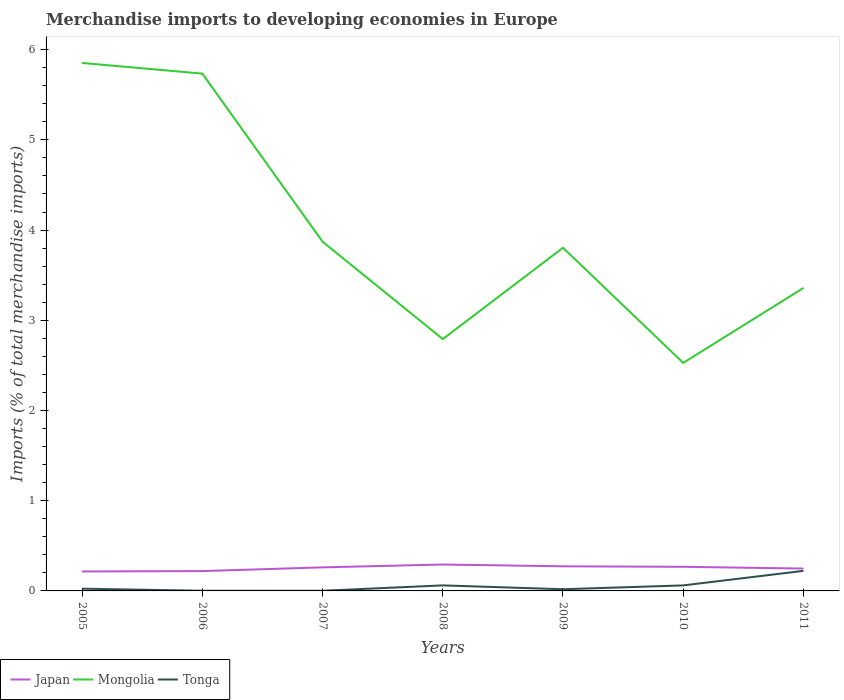Across all years, what is the maximum percentage total merchandise imports in Japan?
Keep it short and to the point. 0.22. What is the total percentage total merchandise imports in Japan in the graph?
Offer a terse response. -0.05. What is the difference between the highest and the second highest percentage total merchandise imports in Mongolia?
Your answer should be compact. 3.32. How many lines are there?
Provide a short and direct response. 3. How many years are there in the graph?
Give a very brief answer. 7. What is the difference between two consecutive major ticks on the Y-axis?
Your answer should be compact. 1. How many legend labels are there?
Offer a very short reply. 3. How are the legend labels stacked?
Offer a terse response. Horizontal. What is the title of the graph?
Your response must be concise. Merchandise imports to developing economies in Europe. Does "Portugal" appear as one of the legend labels in the graph?
Provide a short and direct response. No. What is the label or title of the X-axis?
Your response must be concise. Years. What is the label or title of the Y-axis?
Your response must be concise. Imports (% of total merchandise imports). What is the Imports (% of total merchandise imports) in Japan in 2005?
Your response must be concise. 0.22. What is the Imports (% of total merchandise imports) in Mongolia in 2005?
Offer a very short reply. 5.85. What is the Imports (% of total merchandise imports) of Tonga in 2005?
Provide a succinct answer. 0.02. What is the Imports (% of total merchandise imports) of Japan in 2006?
Provide a succinct answer. 0.22. What is the Imports (% of total merchandise imports) in Mongolia in 2006?
Ensure brevity in your answer.  5.73. What is the Imports (% of total merchandise imports) of Tonga in 2006?
Your response must be concise. 0. What is the Imports (% of total merchandise imports) of Japan in 2007?
Give a very brief answer. 0.26. What is the Imports (% of total merchandise imports) of Mongolia in 2007?
Keep it short and to the point. 3.87. What is the Imports (% of total merchandise imports) of Tonga in 2007?
Offer a very short reply. 0. What is the Imports (% of total merchandise imports) in Japan in 2008?
Provide a short and direct response. 0.29. What is the Imports (% of total merchandise imports) in Mongolia in 2008?
Provide a short and direct response. 2.79. What is the Imports (% of total merchandise imports) in Tonga in 2008?
Your answer should be very brief. 0.06. What is the Imports (% of total merchandise imports) of Japan in 2009?
Your response must be concise. 0.27. What is the Imports (% of total merchandise imports) in Mongolia in 2009?
Ensure brevity in your answer.  3.8. What is the Imports (% of total merchandise imports) of Tonga in 2009?
Your response must be concise. 0.02. What is the Imports (% of total merchandise imports) of Japan in 2010?
Your response must be concise. 0.27. What is the Imports (% of total merchandise imports) of Mongolia in 2010?
Provide a short and direct response. 2.53. What is the Imports (% of total merchandise imports) of Tonga in 2010?
Offer a terse response. 0.06. What is the Imports (% of total merchandise imports) in Japan in 2011?
Give a very brief answer. 0.25. What is the Imports (% of total merchandise imports) in Mongolia in 2011?
Keep it short and to the point. 3.36. What is the Imports (% of total merchandise imports) of Tonga in 2011?
Your response must be concise. 0.22. Across all years, what is the maximum Imports (% of total merchandise imports) of Japan?
Offer a very short reply. 0.29. Across all years, what is the maximum Imports (% of total merchandise imports) of Mongolia?
Provide a succinct answer. 5.85. Across all years, what is the maximum Imports (% of total merchandise imports) in Tonga?
Make the answer very short. 0.22. Across all years, what is the minimum Imports (% of total merchandise imports) of Japan?
Give a very brief answer. 0.22. Across all years, what is the minimum Imports (% of total merchandise imports) in Mongolia?
Keep it short and to the point. 2.53. Across all years, what is the minimum Imports (% of total merchandise imports) in Tonga?
Keep it short and to the point. 0. What is the total Imports (% of total merchandise imports) of Japan in the graph?
Give a very brief answer. 1.78. What is the total Imports (% of total merchandise imports) in Mongolia in the graph?
Keep it short and to the point. 27.94. What is the total Imports (% of total merchandise imports) in Tonga in the graph?
Ensure brevity in your answer.  0.39. What is the difference between the Imports (% of total merchandise imports) in Japan in 2005 and that in 2006?
Provide a short and direct response. -0. What is the difference between the Imports (% of total merchandise imports) of Mongolia in 2005 and that in 2006?
Your answer should be very brief. 0.12. What is the difference between the Imports (% of total merchandise imports) of Tonga in 2005 and that in 2006?
Provide a succinct answer. 0.02. What is the difference between the Imports (% of total merchandise imports) in Japan in 2005 and that in 2007?
Provide a succinct answer. -0.05. What is the difference between the Imports (% of total merchandise imports) of Mongolia in 2005 and that in 2007?
Your answer should be compact. 1.98. What is the difference between the Imports (% of total merchandise imports) of Tonga in 2005 and that in 2007?
Keep it short and to the point. 0.02. What is the difference between the Imports (% of total merchandise imports) in Japan in 2005 and that in 2008?
Your answer should be compact. -0.08. What is the difference between the Imports (% of total merchandise imports) of Mongolia in 2005 and that in 2008?
Offer a terse response. 3.06. What is the difference between the Imports (% of total merchandise imports) of Tonga in 2005 and that in 2008?
Offer a terse response. -0.04. What is the difference between the Imports (% of total merchandise imports) in Japan in 2005 and that in 2009?
Your answer should be very brief. -0.06. What is the difference between the Imports (% of total merchandise imports) in Mongolia in 2005 and that in 2009?
Your answer should be very brief. 2.05. What is the difference between the Imports (% of total merchandise imports) of Tonga in 2005 and that in 2009?
Make the answer very short. 0.01. What is the difference between the Imports (% of total merchandise imports) in Japan in 2005 and that in 2010?
Your response must be concise. -0.05. What is the difference between the Imports (% of total merchandise imports) of Mongolia in 2005 and that in 2010?
Your response must be concise. 3.32. What is the difference between the Imports (% of total merchandise imports) of Tonga in 2005 and that in 2010?
Your answer should be compact. -0.04. What is the difference between the Imports (% of total merchandise imports) in Japan in 2005 and that in 2011?
Offer a terse response. -0.03. What is the difference between the Imports (% of total merchandise imports) in Mongolia in 2005 and that in 2011?
Offer a very short reply. 2.49. What is the difference between the Imports (% of total merchandise imports) in Tonga in 2005 and that in 2011?
Your answer should be compact. -0.2. What is the difference between the Imports (% of total merchandise imports) of Japan in 2006 and that in 2007?
Provide a succinct answer. -0.04. What is the difference between the Imports (% of total merchandise imports) in Mongolia in 2006 and that in 2007?
Provide a succinct answer. 1.86. What is the difference between the Imports (% of total merchandise imports) of Tonga in 2006 and that in 2007?
Ensure brevity in your answer.  -0. What is the difference between the Imports (% of total merchandise imports) of Japan in 2006 and that in 2008?
Offer a very short reply. -0.07. What is the difference between the Imports (% of total merchandise imports) in Mongolia in 2006 and that in 2008?
Make the answer very short. 2.94. What is the difference between the Imports (% of total merchandise imports) in Tonga in 2006 and that in 2008?
Make the answer very short. -0.06. What is the difference between the Imports (% of total merchandise imports) in Japan in 2006 and that in 2009?
Your answer should be very brief. -0.05. What is the difference between the Imports (% of total merchandise imports) of Mongolia in 2006 and that in 2009?
Your answer should be compact. 1.93. What is the difference between the Imports (% of total merchandise imports) of Tonga in 2006 and that in 2009?
Keep it short and to the point. -0.02. What is the difference between the Imports (% of total merchandise imports) of Japan in 2006 and that in 2010?
Give a very brief answer. -0.05. What is the difference between the Imports (% of total merchandise imports) of Mongolia in 2006 and that in 2010?
Provide a succinct answer. 3.21. What is the difference between the Imports (% of total merchandise imports) of Tonga in 2006 and that in 2010?
Your response must be concise. -0.06. What is the difference between the Imports (% of total merchandise imports) in Japan in 2006 and that in 2011?
Give a very brief answer. -0.03. What is the difference between the Imports (% of total merchandise imports) of Mongolia in 2006 and that in 2011?
Make the answer very short. 2.38. What is the difference between the Imports (% of total merchandise imports) of Tonga in 2006 and that in 2011?
Keep it short and to the point. -0.22. What is the difference between the Imports (% of total merchandise imports) in Japan in 2007 and that in 2008?
Offer a terse response. -0.03. What is the difference between the Imports (% of total merchandise imports) of Mongolia in 2007 and that in 2008?
Ensure brevity in your answer.  1.08. What is the difference between the Imports (% of total merchandise imports) in Tonga in 2007 and that in 2008?
Your answer should be compact. -0.06. What is the difference between the Imports (% of total merchandise imports) of Japan in 2007 and that in 2009?
Give a very brief answer. -0.01. What is the difference between the Imports (% of total merchandise imports) of Mongolia in 2007 and that in 2009?
Give a very brief answer. 0.07. What is the difference between the Imports (% of total merchandise imports) of Tonga in 2007 and that in 2009?
Your response must be concise. -0.02. What is the difference between the Imports (% of total merchandise imports) of Japan in 2007 and that in 2010?
Provide a short and direct response. -0.01. What is the difference between the Imports (% of total merchandise imports) of Mongolia in 2007 and that in 2010?
Ensure brevity in your answer.  1.34. What is the difference between the Imports (% of total merchandise imports) of Tonga in 2007 and that in 2010?
Give a very brief answer. -0.06. What is the difference between the Imports (% of total merchandise imports) in Japan in 2007 and that in 2011?
Give a very brief answer. 0.01. What is the difference between the Imports (% of total merchandise imports) of Mongolia in 2007 and that in 2011?
Provide a succinct answer. 0.51. What is the difference between the Imports (% of total merchandise imports) in Tonga in 2007 and that in 2011?
Provide a short and direct response. -0.22. What is the difference between the Imports (% of total merchandise imports) in Japan in 2008 and that in 2009?
Offer a very short reply. 0.02. What is the difference between the Imports (% of total merchandise imports) of Mongolia in 2008 and that in 2009?
Ensure brevity in your answer.  -1.01. What is the difference between the Imports (% of total merchandise imports) in Tonga in 2008 and that in 2009?
Make the answer very short. 0.04. What is the difference between the Imports (% of total merchandise imports) in Japan in 2008 and that in 2010?
Provide a succinct answer. 0.03. What is the difference between the Imports (% of total merchandise imports) in Mongolia in 2008 and that in 2010?
Give a very brief answer. 0.26. What is the difference between the Imports (% of total merchandise imports) of Japan in 2008 and that in 2011?
Ensure brevity in your answer.  0.04. What is the difference between the Imports (% of total merchandise imports) of Mongolia in 2008 and that in 2011?
Offer a terse response. -0.57. What is the difference between the Imports (% of total merchandise imports) in Tonga in 2008 and that in 2011?
Your response must be concise. -0.16. What is the difference between the Imports (% of total merchandise imports) of Japan in 2009 and that in 2010?
Your response must be concise. 0.01. What is the difference between the Imports (% of total merchandise imports) of Mongolia in 2009 and that in 2010?
Give a very brief answer. 1.28. What is the difference between the Imports (% of total merchandise imports) of Tonga in 2009 and that in 2010?
Provide a short and direct response. -0.04. What is the difference between the Imports (% of total merchandise imports) of Japan in 2009 and that in 2011?
Provide a succinct answer. 0.02. What is the difference between the Imports (% of total merchandise imports) of Mongolia in 2009 and that in 2011?
Your response must be concise. 0.45. What is the difference between the Imports (% of total merchandise imports) of Tonga in 2009 and that in 2011?
Your answer should be very brief. -0.2. What is the difference between the Imports (% of total merchandise imports) of Japan in 2010 and that in 2011?
Offer a terse response. 0.02. What is the difference between the Imports (% of total merchandise imports) in Mongolia in 2010 and that in 2011?
Offer a terse response. -0.83. What is the difference between the Imports (% of total merchandise imports) of Tonga in 2010 and that in 2011?
Your response must be concise. -0.16. What is the difference between the Imports (% of total merchandise imports) in Japan in 2005 and the Imports (% of total merchandise imports) in Mongolia in 2006?
Your answer should be very brief. -5.52. What is the difference between the Imports (% of total merchandise imports) of Japan in 2005 and the Imports (% of total merchandise imports) of Tonga in 2006?
Give a very brief answer. 0.21. What is the difference between the Imports (% of total merchandise imports) of Mongolia in 2005 and the Imports (% of total merchandise imports) of Tonga in 2006?
Provide a short and direct response. 5.85. What is the difference between the Imports (% of total merchandise imports) in Japan in 2005 and the Imports (% of total merchandise imports) in Mongolia in 2007?
Provide a short and direct response. -3.66. What is the difference between the Imports (% of total merchandise imports) in Japan in 2005 and the Imports (% of total merchandise imports) in Tonga in 2007?
Offer a very short reply. 0.21. What is the difference between the Imports (% of total merchandise imports) in Mongolia in 2005 and the Imports (% of total merchandise imports) in Tonga in 2007?
Offer a terse response. 5.85. What is the difference between the Imports (% of total merchandise imports) in Japan in 2005 and the Imports (% of total merchandise imports) in Mongolia in 2008?
Provide a succinct answer. -2.58. What is the difference between the Imports (% of total merchandise imports) in Japan in 2005 and the Imports (% of total merchandise imports) in Tonga in 2008?
Offer a terse response. 0.15. What is the difference between the Imports (% of total merchandise imports) of Mongolia in 2005 and the Imports (% of total merchandise imports) of Tonga in 2008?
Offer a very short reply. 5.79. What is the difference between the Imports (% of total merchandise imports) of Japan in 2005 and the Imports (% of total merchandise imports) of Mongolia in 2009?
Your response must be concise. -3.59. What is the difference between the Imports (% of total merchandise imports) in Japan in 2005 and the Imports (% of total merchandise imports) in Tonga in 2009?
Provide a short and direct response. 0.2. What is the difference between the Imports (% of total merchandise imports) in Mongolia in 2005 and the Imports (% of total merchandise imports) in Tonga in 2009?
Your answer should be very brief. 5.83. What is the difference between the Imports (% of total merchandise imports) of Japan in 2005 and the Imports (% of total merchandise imports) of Mongolia in 2010?
Offer a very short reply. -2.31. What is the difference between the Imports (% of total merchandise imports) of Japan in 2005 and the Imports (% of total merchandise imports) of Tonga in 2010?
Make the answer very short. 0.15. What is the difference between the Imports (% of total merchandise imports) in Mongolia in 2005 and the Imports (% of total merchandise imports) in Tonga in 2010?
Your answer should be compact. 5.79. What is the difference between the Imports (% of total merchandise imports) of Japan in 2005 and the Imports (% of total merchandise imports) of Mongolia in 2011?
Your answer should be very brief. -3.14. What is the difference between the Imports (% of total merchandise imports) of Japan in 2005 and the Imports (% of total merchandise imports) of Tonga in 2011?
Keep it short and to the point. -0.01. What is the difference between the Imports (% of total merchandise imports) of Mongolia in 2005 and the Imports (% of total merchandise imports) of Tonga in 2011?
Your answer should be compact. 5.63. What is the difference between the Imports (% of total merchandise imports) in Japan in 2006 and the Imports (% of total merchandise imports) in Mongolia in 2007?
Provide a short and direct response. -3.65. What is the difference between the Imports (% of total merchandise imports) in Japan in 2006 and the Imports (% of total merchandise imports) in Tonga in 2007?
Your answer should be compact. 0.22. What is the difference between the Imports (% of total merchandise imports) in Mongolia in 2006 and the Imports (% of total merchandise imports) in Tonga in 2007?
Make the answer very short. 5.73. What is the difference between the Imports (% of total merchandise imports) of Japan in 2006 and the Imports (% of total merchandise imports) of Mongolia in 2008?
Your answer should be very brief. -2.57. What is the difference between the Imports (% of total merchandise imports) of Japan in 2006 and the Imports (% of total merchandise imports) of Tonga in 2008?
Your answer should be very brief. 0.16. What is the difference between the Imports (% of total merchandise imports) in Mongolia in 2006 and the Imports (% of total merchandise imports) in Tonga in 2008?
Offer a very short reply. 5.67. What is the difference between the Imports (% of total merchandise imports) of Japan in 2006 and the Imports (% of total merchandise imports) of Mongolia in 2009?
Offer a terse response. -3.58. What is the difference between the Imports (% of total merchandise imports) of Japan in 2006 and the Imports (% of total merchandise imports) of Tonga in 2009?
Offer a terse response. 0.2. What is the difference between the Imports (% of total merchandise imports) of Mongolia in 2006 and the Imports (% of total merchandise imports) of Tonga in 2009?
Give a very brief answer. 5.72. What is the difference between the Imports (% of total merchandise imports) of Japan in 2006 and the Imports (% of total merchandise imports) of Mongolia in 2010?
Make the answer very short. -2.31. What is the difference between the Imports (% of total merchandise imports) in Japan in 2006 and the Imports (% of total merchandise imports) in Tonga in 2010?
Make the answer very short. 0.16. What is the difference between the Imports (% of total merchandise imports) in Mongolia in 2006 and the Imports (% of total merchandise imports) in Tonga in 2010?
Keep it short and to the point. 5.67. What is the difference between the Imports (% of total merchandise imports) in Japan in 2006 and the Imports (% of total merchandise imports) in Mongolia in 2011?
Offer a very short reply. -3.14. What is the difference between the Imports (% of total merchandise imports) of Japan in 2006 and the Imports (% of total merchandise imports) of Tonga in 2011?
Offer a very short reply. -0. What is the difference between the Imports (% of total merchandise imports) of Mongolia in 2006 and the Imports (% of total merchandise imports) of Tonga in 2011?
Provide a short and direct response. 5.51. What is the difference between the Imports (% of total merchandise imports) in Japan in 2007 and the Imports (% of total merchandise imports) in Mongolia in 2008?
Make the answer very short. -2.53. What is the difference between the Imports (% of total merchandise imports) in Japan in 2007 and the Imports (% of total merchandise imports) in Tonga in 2008?
Give a very brief answer. 0.2. What is the difference between the Imports (% of total merchandise imports) in Mongolia in 2007 and the Imports (% of total merchandise imports) in Tonga in 2008?
Offer a terse response. 3.81. What is the difference between the Imports (% of total merchandise imports) of Japan in 2007 and the Imports (% of total merchandise imports) of Mongolia in 2009?
Keep it short and to the point. -3.54. What is the difference between the Imports (% of total merchandise imports) in Japan in 2007 and the Imports (% of total merchandise imports) in Tonga in 2009?
Give a very brief answer. 0.24. What is the difference between the Imports (% of total merchandise imports) in Mongolia in 2007 and the Imports (% of total merchandise imports) in Tonga in 2009?
Ensure brevity in your answer.  3.85. What is the difference between the Imports (% of total merchandise imports) of Japan in 2007 and the Imports (% of total merchandise imports) of Mongolia in 2010?
Your answer should be compact. -2.27. What is the difference between the Imports (% of total merchandise imports) in Mongolia in 2007 and the Imports (% of total merchandise imports) in Tonga in 2010?
Your answer should be compact. 3.81. What is the difference between the Imports (% of total merchandise imports) in Japan in 2007 and the Imports (% of total merchandise imports) in Mongolia in 2011?
Provide a short and direct response. -3.1. What is the difference between the Imports (% of total merchandise imports) of Japan in 2007 and the Imports (% of total merchandise imports) of Tonga in 2011?
Provide a succinct answer. 0.04. What is the difference between the Imports (% of total merchandise imports) in Mongolia in 2007 and the Imports (% of total merchandise imports) in Tonga in 2011?
Offer a terse response. 3.65. What is the difference between the Imports (% of total merchandise imports) in Japan in 2008 and the Imports (% of total merchandise imports) in Mongolia in 2009?
Offer a terse response. -3.51. What is the difference between the Imports (% of total merchandise imports) of Japan in 2008 and the Imports (% of total merchandise imports) of Tonga in 2009?
Keep it short and to the point. 0.27. What is the difference between the Imports (% of total merchandise imports) of Mongolia in 2008 and the Imports (% of total merchandise imports) of Tonga in 2009?
Provide a succinct answer. 2.77. What is the difference between the Imports (% of total merchandise imports) of Japan in 2008 and the Imports (% of total merchandise imports) of Mongolia in 2010?
Offer a very short reply. -2.24. What is the difference between the Imports (% of total merchandise imports) in Japan in 2008 and the Imports (% of total merchandise imports) in Tonga in 2010?
Provide a short and direct response. 0.23. What is the difference between the Imports (% of total merchandise imports) of Mongolia in 2008 and the Imports (% of total merchandise imports) of Tonga in 2010?
Your response must be concise. 2.73. What is the difference between the Imports (% of total merchandise imports) of Japan in 2008 and the Imports (% of total merchandise imports) of Mongolia in 2011?
Provide a succinct answer. -3.07. What is the difference between the Imports (% of total merchandise imports) of Japan in 2008 and the Imports (% of total merchandise imports) of Tonga in 2011?
Provide a succinct answer. 0.07. What is the difference between the Imports (% of total merchandise imports) in Mongolia in 2008 and the Imports (% of total merchandise imports) in Tonga in 2011?
Make the answer very short. 2.57. What is the difference between the Imports (% of total merchandise imports) in Japan in 2009 and the Imports (% of total merchandise imports) in Mongolia in 2010?
Your answer should be compact. -2.25. What is the difference between the Imports (% of total merchandise imports) in Japan in 2009 and the Imports (% of total merchandise imports) in Tonga in 2010?
Offer a very short reply. 0.21. What is the difference between the Imports (% of total merchandise imports) of Mongolia in 2009 and the Imports (% of total merchandise imports) of Tonga in 2010?
Your answer should be compact. 3.74. What is the difference between the Imports (% of total merchandise imports) of Japan in 2009 and the Imports (% of total merchandise imports) of Mongolia in 2011?
Make the answer very short. -3.09. What is the difference between the Imports (% of total merchandise imports) of Japan in 2009 and the Imports (% of total merchandise imports) of Tonga in 2011?
Provide a short and direct response. 0.05. What is the difference between the Imports (% of total merchandise imports) in Mongolia in 2009 and the Imports (% of total merchandise imports) in Tonga in 2011?
Ensure brevity in your answer.  3.58. What is the difference between the Imports (% of total merchandise imports) in Japan in 2010 and the Imports (% of total merchandise imports) in Mongolia in 2011?
Give a very brief answer. -3.09. What is the difference between the Imports (% of total merchandise imports) in Japan in 2010 and the Imports (% of total merchandise imports) in Tonga in 2011?
Ensure brevity in your answer.  0.04. What is the difference between the Imports (% of total merchandise imports) in Mongolia in 2010 and the Imports (% of total merchandise imports) in Tonga in 2011?
Offer a terse response. 2.31. What is the average Imports (% of total merchandise imports) in Japan per year?
Give a very brief answer. 0.25. What is the average Imports (% of total merchandise imports) in Mongolia per year?
Ensure brevity in your answer.  3.99. What is the average Imports (% of total merchandise imports) in Tonga per year?
Provide a short and direct response. 0.06. In the year 2005, what is the difference between the Imports (% of total merchandise imports) in Japan and Imports (% of total merchandise imports) in Mongolia?
Provide a short and direct response. -5.64. In the year 2005, what is the difference between the Imports (% of total merchandise imports) in Japan and Imports (% of total merchandise imports) in Tonga?
Keep it short and to the point. 0.19. In the year 2005, what is the difference between the Imports (% of total merchandise imports) in Mongolia and Imports (% of total merchandise imports) in Tonga?
Make the answer very short. 5.83. In the year 2006, what is the difference between the Imports (% of total merchandise imports) in Japan and Imports (% of total merchandise imports) in Mongolia?
Your answer should be compact. -5.51. In the year 2006, what is the difference between the Imports (% of total merchandise imports) in Japan and Imports (% of total merchandise imports) in Tonga?
Your answer should be compact. 0.22. In the year 2006, what is the difference between the Imports (% of total merchandise imports) of Mongolia and Imports (% of total merchandise imports) of Tonga?
Give a very brief answer. 5.73. In the year 2007, what is the difference between the Imports (% of total merchandise imports) in Japan and Imports (% of total merchandise imports) in Mongolia?
Provide a short and direct response. -3.61. In the year 2007, what is the difference between the Imports (% of total merchandise imports) in Japan and Imports (% of total merchandise imports) in Tonga?
Make the answer very short. 0.26. In the year 2007, what is the difference between the Imports (% of total merchandise imports) in Mongolia and Imports (% of total merchandise imports) in Tonga?
Provide a short and direct response. 3.87. In the year 2008, what is the difference between the Imports (% of total merchandise imports) of Japan and Imports (% of total merchandise imports) of Mongolia?
Your response must be concise. -2.5. In the year 2008, what is the difference between the Imports (% of total merchandise imports) in Japan and Imports (% of total merchandise imports) in Tonga?
Your answer should be very brief. 0.23. In the year 2008, what is the difference between the Imports (% of total merchandise imports) of Mongolia and Imports (% of total merchandise imports) of Tonga?
Provide a short and direct response. 2.73. In the year 2009, what is the difference between the Imports (% of total merchandise imports) of Japan and Imports (% of total merchandise imports) of Mongolia?
Your answer should be very brief. -3.53. In the year 2009, what is the difference between the Imports (% of total merchandise imports) of Japan and Imports (% of total merchandise imports) of Tonga?
Your response must be concise. 0.25. In the year 2009, what is the difference between the Imports (% of total merchandise imports) of Mongolia and Imports (% of total merchandise imports) of Tonga?
Provide a short and direct response. 3.79. In the year 2010, what is the difference between the Imports (% of total merchandise imports) of Japan and Imports (% of total merchandise imports) of Mongolia?
Give a very brief answer. -2.26. In the year 2010, what is the difference between the Imports (% of total merchandise imports) of Japan and Imports (% of total merchandise imports) of Tonga?
Offer a terse response. 0.21. In the year 2010, what is the difference between the Imports (% of total merchandise imports) of Mongolia and Imports (% of total merchandise imports) of Tonga?
Offer a terse response. 2.47. In the year 2011, what is the difference between the Imports (% of total merchandise imports) of Japan and Imports (% of total merchandise imports) of Mongolia?
Provide a succinct answer. -3.11. In the year 2011, what is the difference between the Imports (% of total merchandise imports) of Japan and Imports (% of total merchandise imports) of Tonga?
Your answer should be very brief. 0.03. In the year 2011, what is the difference between the Imports (% of total merchandise imports) of Mongolia and Imports (% of total merchandise imports) of Tonga?
Make the answer very short. 3.14. What is the ratio of the Imports (% of total merchandise imports) of Japan in 2005 to that in 2006?
Your answer should be compact. 0.98. What is the ratio of the Imports (% of total merchandise imports) in Mongolia in 2005 to that in 2006?
Provide a short and direct response. 1.02. What is the ratio of the Imports (% of total merchandise imports) of Tonga in 2005 to that in 2006?
Your answer should be compact. 13.4. What is the ratio of the Imports (% of total merchandise imports) of Japan in 2005 to that in 2007?
Offer a terse response. 0.82. What is the ratio of the Imports (% of total merchandise imports) of Mongolia in 2005 to that in 2007?
Give a very brief answer. 1.51. What is the ratio of the Imports (% of total merchandise imports) of Tonga in 2005 to that in 2007?
Offer a terse response. 13.04. What is the ratio of the Imports (% of total merchandise imports) in Japan in 2005 to that in 2008?
Provide a succinct answer. 0.74. What is the ratio of the Imports (% of total merchandise imports) of Mongolia in 2005 to that in 2008?
Offer a terse response. 2.1. What is the ratio of the Imports (% of total merchandise imports) in Tonga in 2005 to that in 2008?
Make the answer very short. 0.41. What is the ratio of the Imports (% of total merchandise imports) in Japan in 2005 to that in 2009?
Ensure brevity in your answer.  0.79. What is the ratio of the Imports (% of total merchandise imports) in Mongolia in 2005 to that in 2009?
Your answer should be very brief. 1.54. What is the ratio of the Imports (% of total merchandise imports) of Tonga in 2005 to that in 2009?
Give a very brief answer. 1.33. What is the ratio of the Imports (% of total merchandise imports) of Japan in 2005 to that in 2010?
Your answer should be very brief. 0.81. What is the ratio of the Imports (% of total merchandise imports) in Mongolia in 2005 to that in 2010?
Keep it short and to the point. 2.32. What is the ratio of the Imports (% of total merchandise imports) in Tonga in 2005 to that in 2010?
Your answer should be compact. 0.41. What is the ratio of the Imports (% of total merchandise imports) of Japan in 2005 to that in 2011?
Offer a very short reply. 0.87. What is the ratio of the Imports (% of total merchandise imports) of Mongolia in 2005 to that in 2011?
Offer a terse response. 1.74. What is the ratio of the Imports (% of total merchandise imports) of Tonga in 2005 to that in 2011?
Give a very brief answer. 0.11. What is the ratio of the Imports (% of total merchandise imports) in Japan in 2006 to that in 2007?
Give a very brief answer. 0.84. What is the ratio of the Imports (% of total merchandise imports) of Mongolia in 2006 to that in 2007?
Offer a terse response. 1.48. What is the ratio of the Imports (% of total merchandise imports) in Tonga in 2006 to that in 2007?
Offer a terse response. 0.97. What is the ratio of the Imports (% of total merchandise imports) of Japan in 2006 to that in 2008?
Provide a succinct answer. 0.75. What is the ratio of the Imports (% of total merchandise imports) of Mongolia in 2006 to that in 2008?
Make the answer very short. 2.05. What is the ratio of the Imports (% of total merchandise imports) of Tonga in 2006 to that in 2008?
Offer a very short reply. 0.03. What is the ratio of the Imports (% of total merchandise imports) of Japan in 2006 to that in 2009?
Give a very brief answer. 0.81. What is the ratio of the Imports (% of total merchandise imports) of Mongolia in 2006 to that in 2009?
Keep it short and to the point. 1.51. What is the ratio of the Imports (% of total merchandise imports) of Tonga in 2006 to that in 2009?
Offer a very short reply. 0.1. What is the ratio of the Imports (% of total merchandise imports) of Japan in 2006 to that in 2010?
Give a very brief answer. 0.82. What is the ratio of the Imports (% of total merchandise imports) in Mongolia in 2006 to that in 2010?
Offer a very short reply. 2.27. What is the ratio of the Imports (% of total merchandise imports) of Tonga in 2006 to that in 2010?
Provide a short and direct response. 0.03. What is the ratio of the Imports (% of total merchandise imports) of Japan in 2006 to that in 2011?
Make the answer very short. 0.89. What is the ratio of the Imports (% of total merchandise imports) in Mongolia in 2006 to that in 2011?
Offer a terse response. 1.71. What is the ratio of the Imports (% of total merchandise imports) in Tonga in 2006 to that in 2011?
Keep it short and to the point. 0.01. What is the ratio of the Imports (% of total merchandise imports) of Japan in 2007 to that in 2008?
Offer a very short reply. 0.89. What is the ratio of the Imports (% of total merchandise imports) in Mongolia in 2007 to that in 2008?
Offer a terse response. 1.39. What is the ratio of the Imports (% of total merchandise imports) in Tonga in 2007 to that in 2008?
Make the answer very short. 0.03. What is the ratio of the Imports (% of total merchandise imports) of Japan in 2007 to that in 2009?
Ensure brevity in your answer.  0.96. What is the ratio of the Imports (% of total merchandise imports) of Mongolia in 2007 to that in 2009?
Keep it short and to the point. 1.02. What is the ratio of the Imports (% of total merchandise imports) in Tonga in 2007 to that in 2009?
Your response must be concise. 0.1. What is the ratio of the Imports (% of total merchandise imports) in Japan in 2007 to that in 2010?
Ensure brevity in your answer.  0.98. What is the ratio of the Imports (% of total merchandise imports) in Mongolia in 2007 to that in 2010?
Your answer should be compact. 1.53. What is the ratio of the Imports (% of total merchandise imports) of Tonga in 2007 to that in 2010?
Your answer should be compact. 0.03. What is the ratio of the Imports (% of total merchandise imports) in Japan in 2007 to that in 2011?
Make the answer very short. 1.05. What is the ratio of the Imports (% of total merchandise imports) in Mongolia in 2007 to that in 2011?
Your answer should be compact. 1.15. What is the ratio of the Imports (% of total merchandise imports) in Tonga in 2007 to that in 2011?
Offer a terse response. 0.01. What is the ratio of the Imports (% of total merchandise imports) of Japan in 2008 to that in 2009?
Your answer should be very brief. 1.07. What is the ratio of the Imports (% of total merchandise imports) in Mongolia in 2008 to that in 2009?
Offer a very short reply. 0.73. What is the ratio of the Imports (% of total merchandise imports) of Tonga in 2008 to that in 2009?
Give a very brief answer. 3.28. What is the ratio of the Imports (% of total merchandise imports) in Japan in 2008 to that in 2010?
Keep it short and to the point. 1.09. What is the ratio of the Imports (% of total merchandise imports) of Mongolia in 2008 to that in 2010?
Your answer should be very brief. 1.1. What is the ratio of the Imports (% of total merchandise imports) in Tonga in 2008 to that in 2010?
Provide a short and direct response. 1. What is the ratio of the Imports (% of total merchandise imports) in Japan in 2008 to that in 2011?
Give a very brief answer. 1.18. What is the ratio of the Imports (% of total merchandise imports) of Mongolia in 2008 to that in 2011?
Offer a very short reply. 0.83. What is the ratio of the Imports (% of total merchandise imports) in Tonga in 2008 to that in 2011?
Make the answer very short. 0.28. What is the ratio of the Imports (% of total merchandise imports) in Japan in 2009 to that in 2010?
Your answer should be very brief. 1.02. What is the ratio of the Imports (% of total merchandise imports) of Mongolia in 2009 to that in 2010?
Provide a succinct answer. 1.5. What is the ratio of the Imports (% of total merchandise imports) in Tonga in 2009 to that in 2010?
Provide a short and direct response. 0.31. What is the ratio of the Imports (% of total merchandise imports) in Japan in 2009 to that in 2011?
Ensure brevity in your answer.  1.1. What is the ratio of the Imports (% of total merchandise imports) in Mongolia in 2009 to that in 2011?
Offer a very short reply. 1.13. What is the ratio of the Imports (% of total merchandise imports) in Tonga in 2009 to that in 2011?
Your answer should be compact. 0.08. What is the ratio of the Imports (% of total merchandise imports) of Japan in 2010 to that in 2011?
Offer a terse response. 1.08. What is the ratio of the Imports (% of total merchandise imports) of Mongolia in 2010 to that in 2011?
Your answer should be compact. 0.75. What is the ratio of the Imports (% of total merchandise imports) of Tonga in 2010 to that in 2011?
Your answer should be very brief. 0.28. What is the difference between the highest and the second highest Imports (% of total merchandise imports) in Japan?
Your response must be concise. 0.02. What is the difference between the highest and the second highest Imports (% of total merchandise imports) of Mongolia?
Your answer should be compact. 0.12. What is the difference between the highest and the second highest Imports (% of total merchandise imports) of Tonga?
Make the answer very short. 0.16. What is the difference between the highest and the lowest Imports (% of total merchandise imports) of Japan?
Provide a succinct answer. 0.08. What is the difference between the highest and the lowest Imports (% of total merchandise imports) of Mongolia?
Offer a very short reply. 3.32. What is the difference between the highest and the lowest Imports (% of total merchandise imports) of Tonga?
Provide a succinct answer. 0.22. 